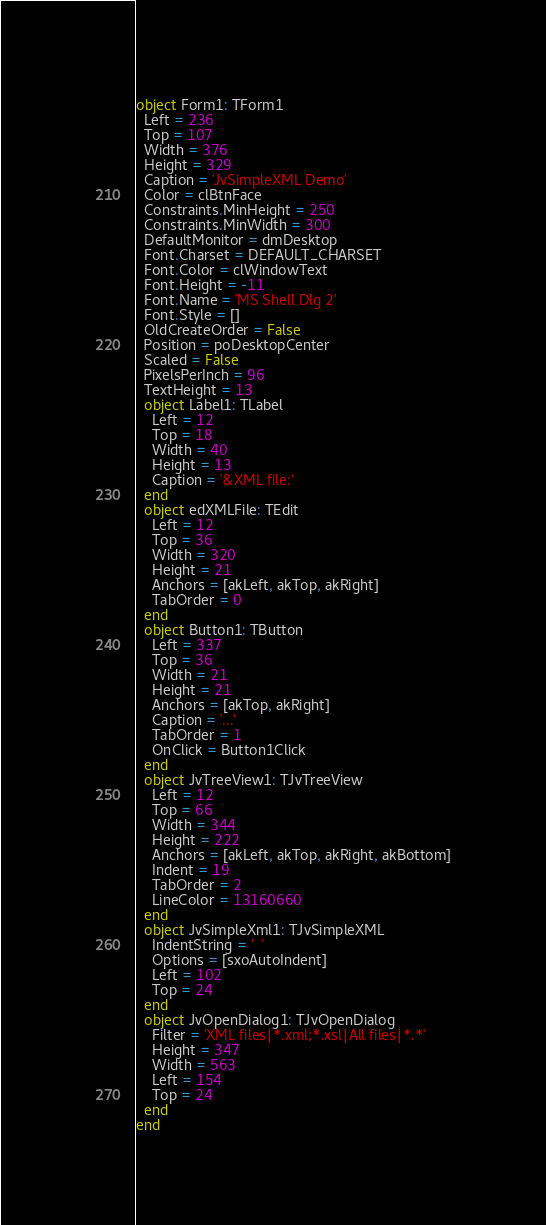<code> <loc_0><loc_0><loc_500><loc_500><_Pascal_>object Form1: TForm1
  Left = 236
  Top = 107
  Width = 376
  Height = 329
  Caption = 'JvSimpleXML Demo'
  Color = clBtnFace
  Constraints.MinHeight = 250
  Constraints.MinWidth = 300
  DefaultMonitor = dmDesktop
  Font.Charset = DEFAULT_CHARSET
  Font.Color = clWindowText
  Font.Height = -11
  Font.Name = 'MS Shell Dlg 2'
  Font.Style = []
  OldCreateOrder = False
  Position = poDesktopCenter
  Scaled = False
  PixelsPerInch = 96
  TextHeight = 13
  object Label1: TLabel
    Left = 12
    Top = 18
    Width = 40
    Height = 13
    Caption = '&XML file:'
  end
  object edXMLFile: TEdit
    Left = 12
    Top = 36
    Width = 320
    Height = 21
    Anchors = [akLeft, akTop, akRight]
    TabOrder = 0
  end
  object Button1: TButton
    Left = 337
    Top = 36
    Width = 21
    Height = 21
    Anchors = [akTop, akRight]
    Caption = '...'
    TabOrder = 1
    OnClick = Button1Click
  end
  object JvTreeView1: TJvTreeView
    Left = 12
    Top = 66
    Width = 344
    Height = 222
    Anchors = [akLeft, akTop, akRight, akBottom]
    Indent = 19
    TabOrder = 2
    LineColor = 13160660
  end
  object JvSimpleXml1: TJvSimpleXML
    IndentString = '  '
    Options = [sxoAutoIndent]
    Left = 102
    Top = 24
  end
  object JvOpenDialog1: TJvOpenDialog
    Filter = 'XML files|*.xml;*.xsl|All files|*.*'
    Height = 347
    Width = 563
    Left = 154
    Top = 24
  end
end
</code> 